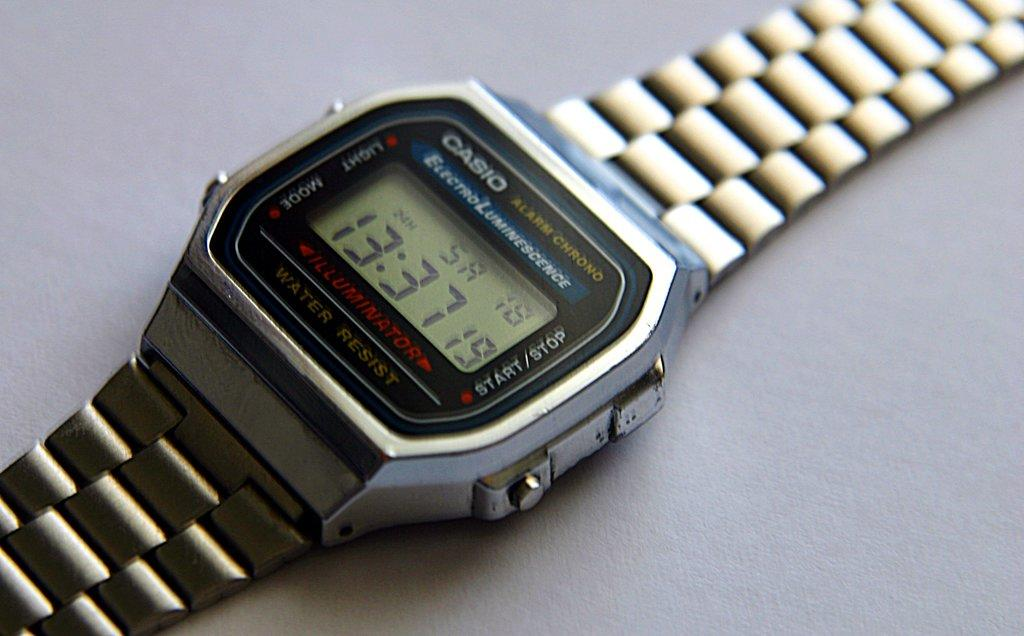Provide a one-sentence caption for the provided image. Casio watch that have the time and stop watch included. 